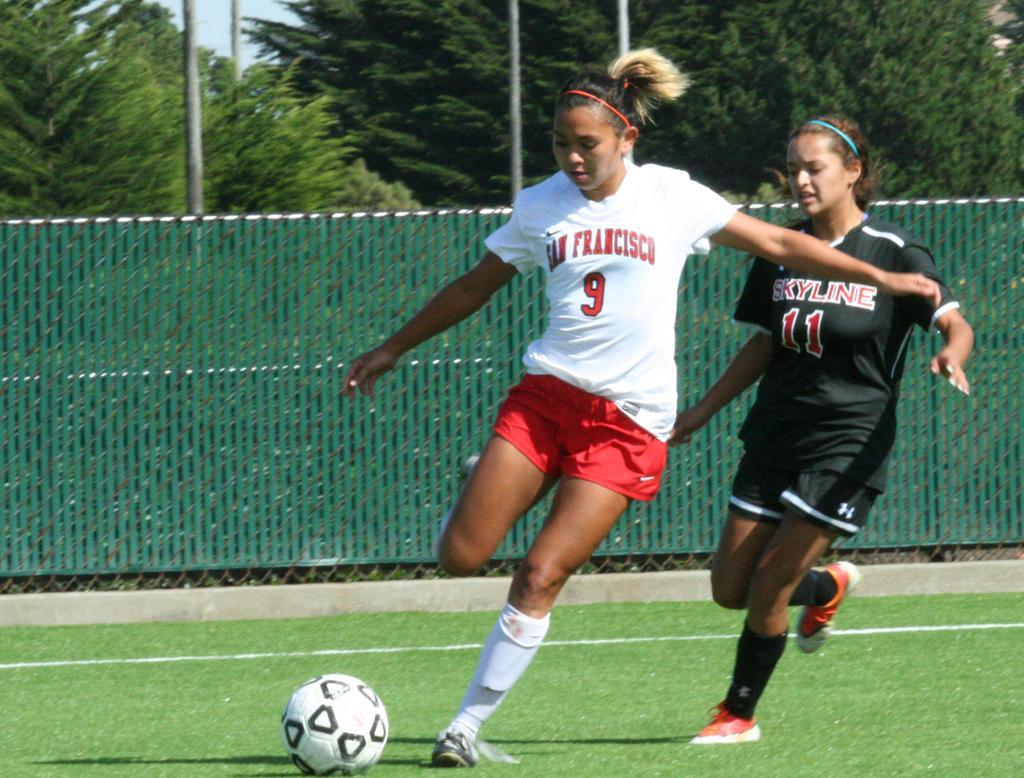Could you give a brief overview of what you see in this image? These two people are running. On the ground there is a ball. Background there is a fence and trees. These are poles.  